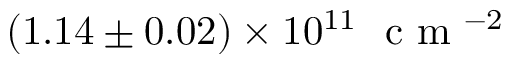<formula> <loc_0><loc_0><loc_500><loc_500>( 1 . 1 4 \pm 0 . 0 2 ) \times 1 0 ^ { 1 1 } c m ^ { - 2 }</formula> 